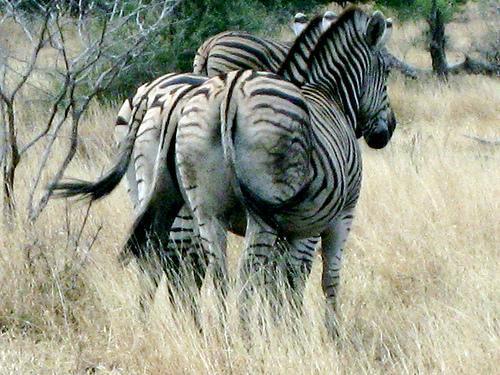How many zebras are there?
Give a very brief answer. 2. 